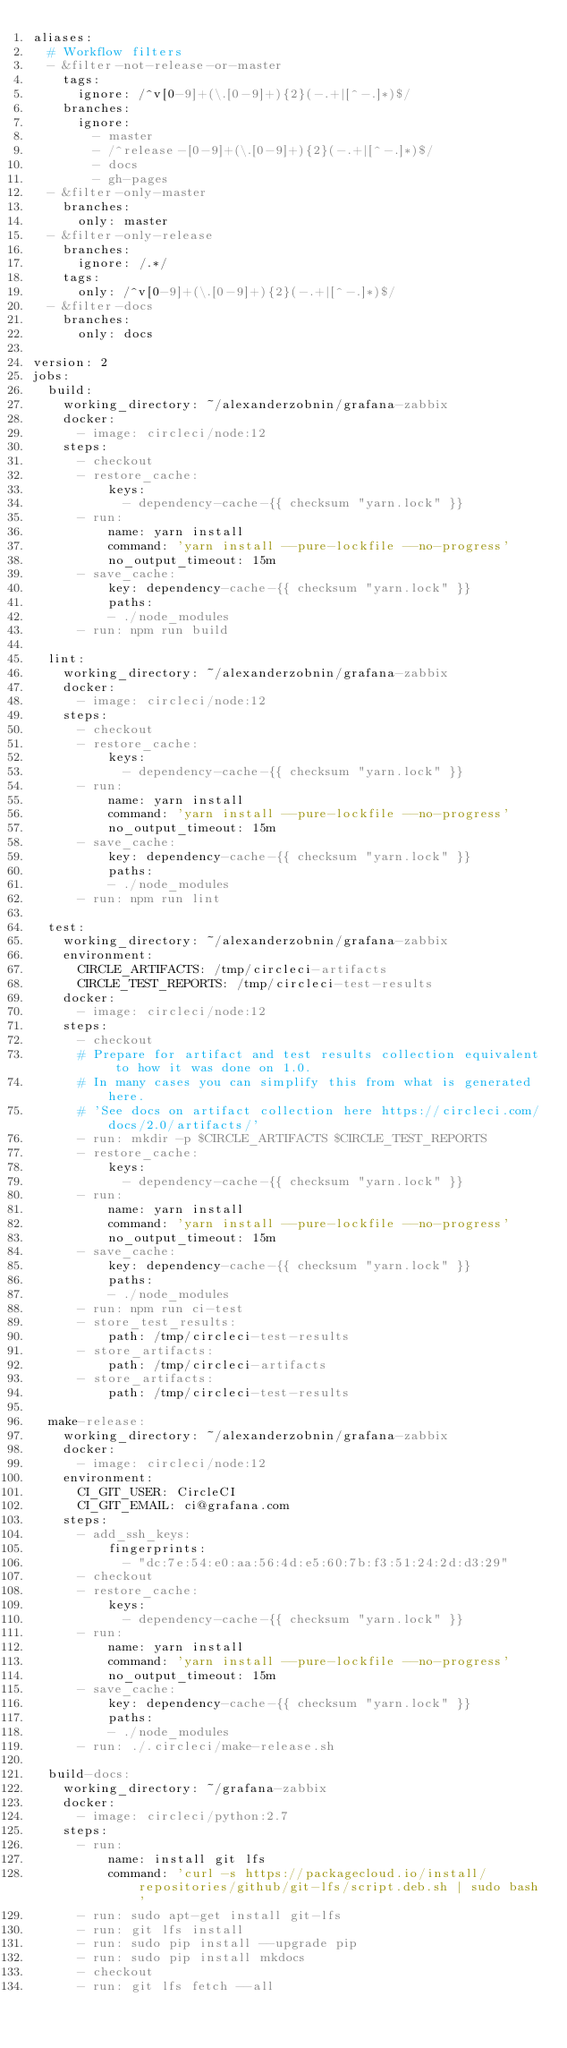Convert code to text. <code><loc_0><loc_0><loc_500><loc_500><_YAML_>aliases:
  # Workflow filters
  - &filter-not-release-or-master
    tags:
      ignore: /^v[0-9]+(\.[0-9]+){2}(-.+|[^-.]*)$/
    branches:
      ignore:
        - master
        - /^release-[0-9]+(\.[0-9]+){2}(-.+|[^-.]*)$/
        - docs
        - gh-pages
  - &filter-only-master
    branches:
      only: master
  - &filter-only-release
    branches:
      ignore: /.*/
    tags:
      only: /^v[0-9]+(\.[0-9]+){2}(-.+|[^-.]*)$/
  - &filter-docs
    branches:
      only: docs

version: 2
jobs:
  build:
    working_directory: ~/alexanderzobnin/grafana-zabbix
    docker:
      - image: circleci/node:12
    steps:
      - checkout
      - restore_cache:
          keys:
            - dependency-cache-{{ checksum "yarn.lock" }}
      - run:
          name: yarn install
          command: 'yarn install --pure-lockfile --no-progress'
          no_output_timeout: 15m
      - save_cache:
          key: dependency-cache-{{ checksum "yarn.lock" }}
          paths:
          - ./node_modules
      - run: npm run build

  lint:
    working_directory: ~/alexanderzobnin/grafana-zabbix
    docker:
      - image: circleci/node:12
    steps:
      - checkout
      - restore_cache:
          keys:
            - dependency-cache-{{ checksum "yarn.lock" }}
      - run:
          name: yarn install
          command: 'yarn install --pure-lockfile --no-progress'
          no_output_timeout: 15m
      - save_cache:
          key: dependency-cache-{{ checksum "yarn.lock" }}
          paths:
          - ./node_modules
      - run: npm run lint

  test:
    working_directory: ~/alexanderzobnin/grafana-zabbix
    environment:
      CIRCLE_ARTIFACTS: /tmp/circleci-artifacts
      CIRCLE_TEST_REPORTS: /tmp/circleci-test-results
    docker:
      - image: circleci/node:12
    steps:
      - checkout
      # Prepare for artifact and test results collection equivalent to how it was done on 1.0.
      # In many cases you can simplify this from what is generated here.
      # 'See docs on artifact collection here https://circleci.com/docs/2.0/artifacts/'
      - run: mkdir -p $CIRCLE_ARTIFACTS $CIRCLE_TEST_REPORTS
      - restore_cache:
          keys:
            - dependency-cache-{{ checksum "yarn.lock" }}
      - run:
          name: yarn install
          command: 'yarn install --pure-lockfile --no-progress'
          no_output_timeout: 15m
      - save_cache:
          key: dependency-cache-{{ checksum "yarn.lock" }}
          paths:
          - ./node_modules
      - run: npm run ci-test
      - store_test_results:
          path: /tmp/circleci-test-results
      - store_artifacts:
          path: /tmp/circleci-artifacts
      - store_artifacts:
          path: /tmp/circleci-test-results

  make-release:
    working_directory: ~/alexanderzobnin/grafana-zabbix
    docker:
      - image: circleci/node:12
    environment:
      CI_GIT_USER: CircleCI
      CI_GIT_EMAIL: ci@grafana.com
    steps:
      - add_ssh_keys:
          fingerprints:
            - "dc:7e:54:e0:aa:56:4d:e5:60:7b:f3:51:24:2d:d3:29"
      - checkout
      - restore_cache:
          keys:
            - dependency-cache-{{ checksum "yarn.lock" }}
      - run:
          name: yarn install
          command: 'yarn install --pure-lockfile --no-progress'
          no_output_timeout: 15m
      - save_cache:
          key: dependency-cache-{{ checksum "yarn.lock" }}
          paths:
          - ./node_modules
      - run: ./.circleci/make-release.sh

  build-docs:
    working_directory: ~/grafana-zabbix
    docker:
      - image: circleci/python:2.7
    steps:
      - run:
          name: install git lfs
          command: 'curl -s https://packagecloud.io/install/repositories/github/git-lfs/script.deb.sh | sudo bash'
      - run: sudo apt-get install git-lfs
      - run: git lfs install
      - run: sudo pip install --upgrade pip
      - run: sudo pip install mkdocs
      - checkout
      - run: git lfs fetch --all</code> 